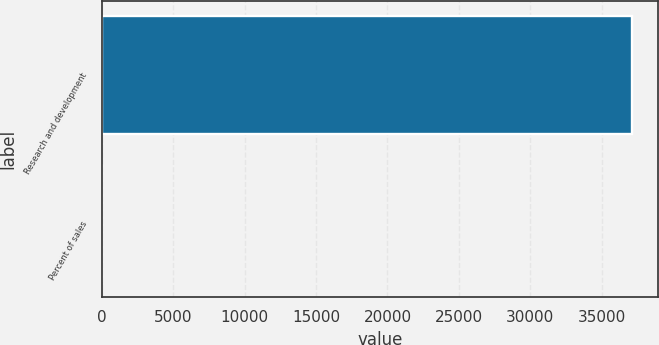<chart> <loc_0><loc_0><loc_500><loc_500><bar_chart><fcel>Research and development<fcel>Percent of sales<nl><fcel>37093<fcel>5.6<nl></chart> 